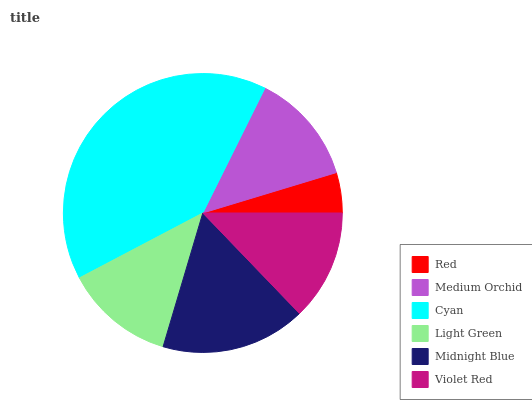Is Red the minimum?
Answer yes or no. Yes. Is Cyan the maximum?
Answer yes or no. Yes. Is Medium Orchid the minimum?
Answer yes or no. No. Is Medium Orchid the maximum?
Answer yes or no. No. Is Medium Orchid greater than Red?
Answer yes or no. Yes. Is Red less than Medium Orchid?
Answer yes or no. Yes. Is Red greater than Medium Orchid?
Answer yes or no. No. Is Medium Orchid less than Red?
Answer yes or no. No. Is Medium Orchid the high median?
Answer yes or no. Yes. Is Violet Red the low median?
Answer yes or no. Yes. Is Cyan the high median?
Answer yes or no. No. Is Light Green the low median?
Answer yes or no. No. 